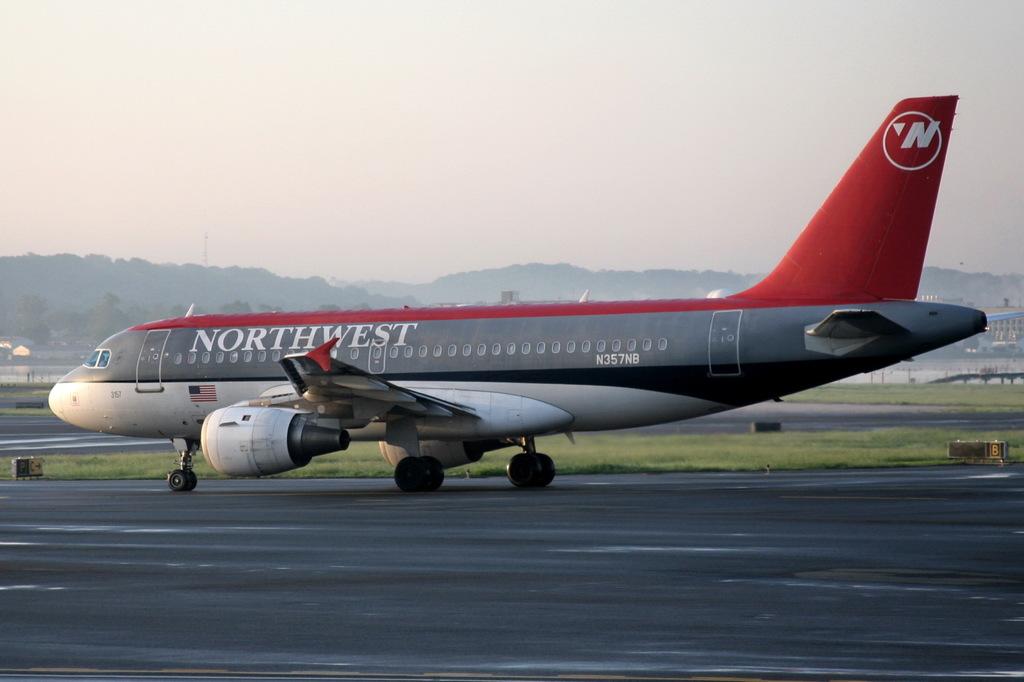What does it say on the airplane?
Keep it short and to the point. Northwest. What is the airline of the plane?
Ensure brevity in your answer.  Northwest. 